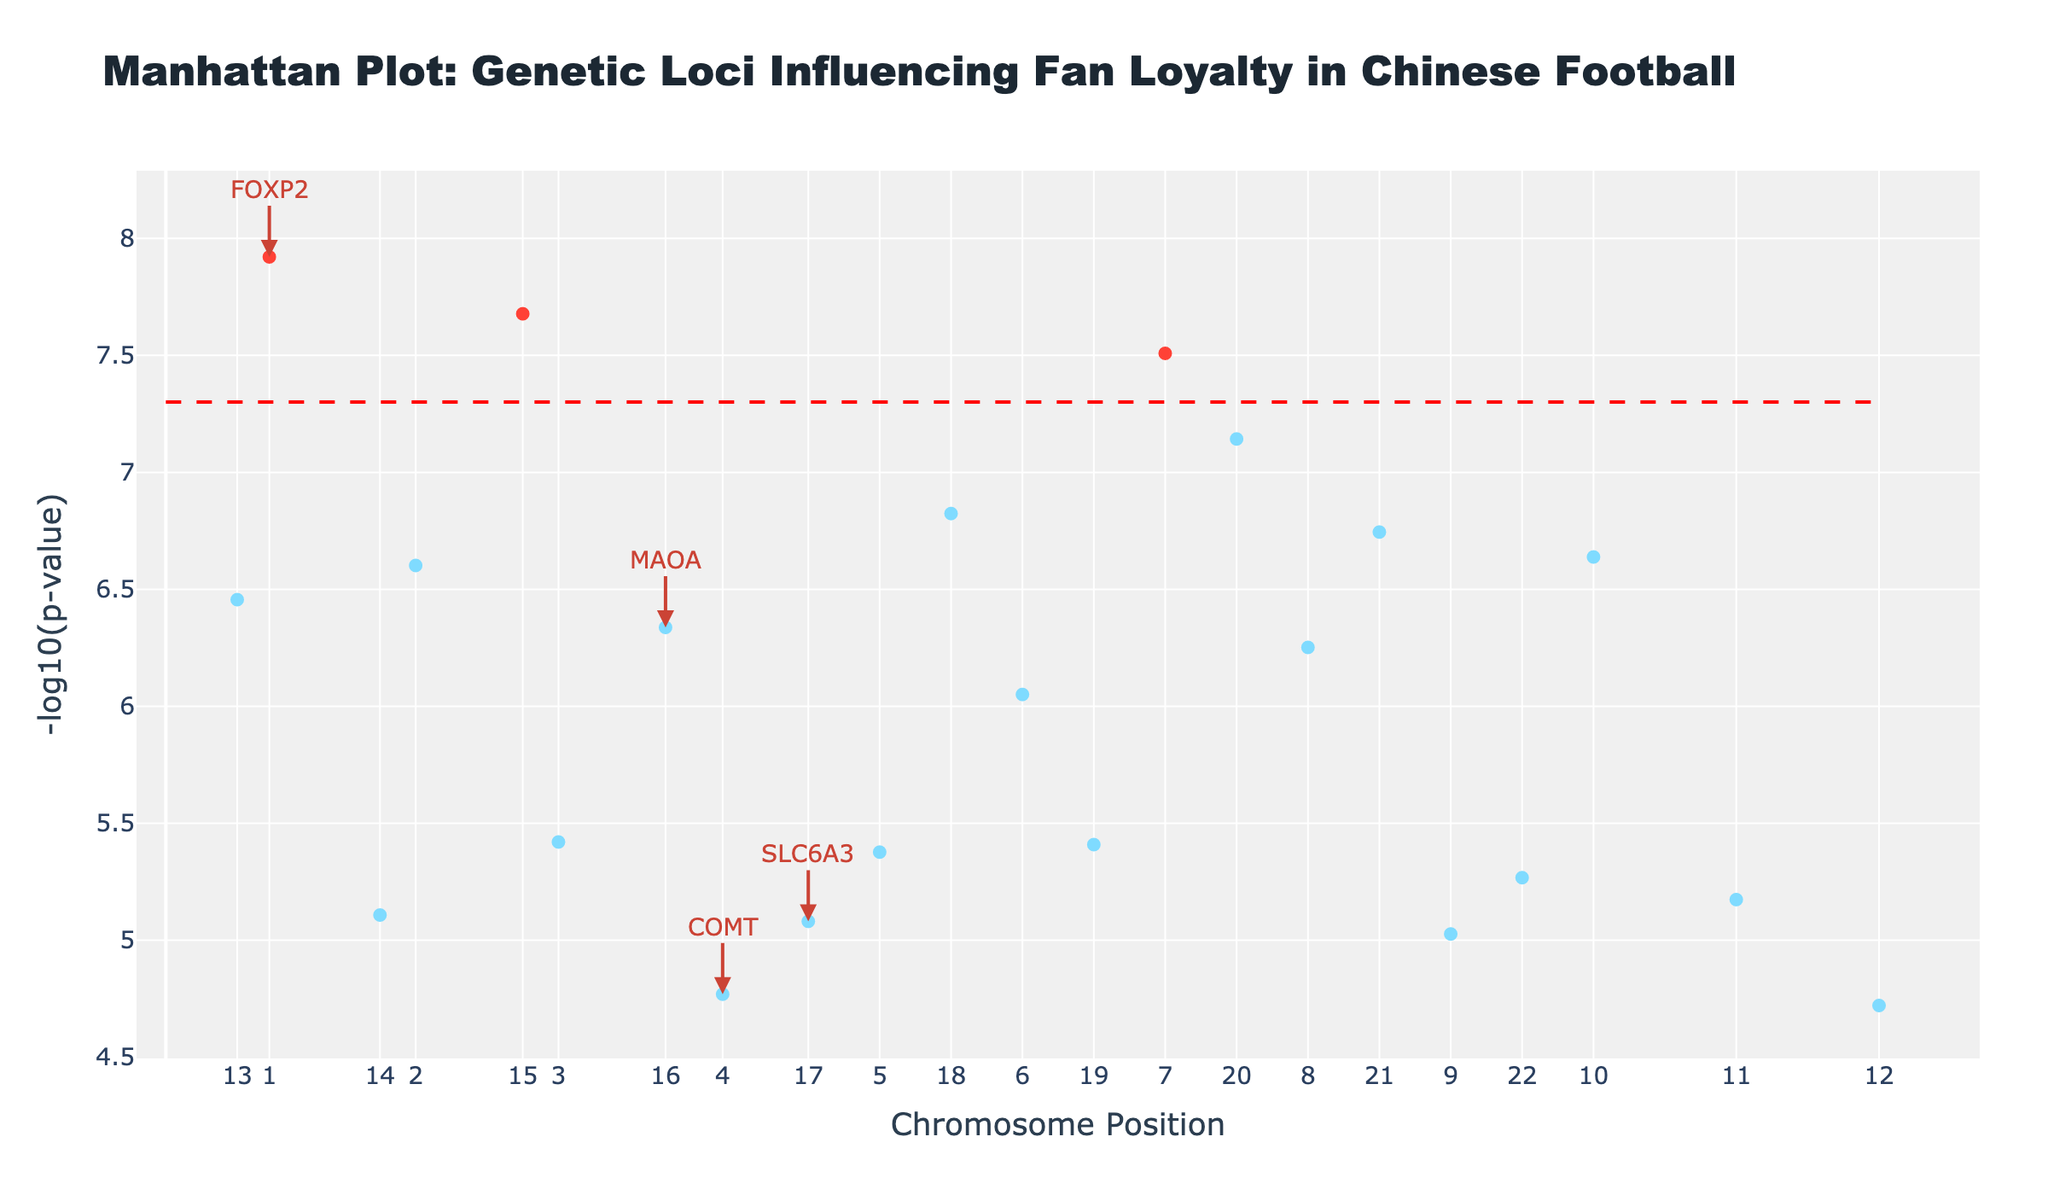what is the title of the plot? By looking at the top of the figure, the title is displayed prominently in larger text. This helps identify the main focus of the plot.
Answer: Manhattan Plot: Genetic Loci Influencing Fan Loyalty in Chinese Football What does the y-axis represent? The y-axis typically shows the significance of each SNP, often represented as the negative logarithm of the p-value (-log10(p-value)). This is found by looking at the y-axis label.
Answer: -log10(p-value) Which SNP has the lowest p-value? By looking for the highest point on the y-axis concerning the -log10(p-value), I can identify the SNP with the lowest p-value. Check the text associated with this highest point to find the SNP name.
Answer: rs2345678 How are significant SNPs visually distinguished? Significant SNPs are usually marked differently, often in a distinct color like red. This can be observed by the presence of differently colored markers in the plot.
Answer: They are in red On which chromosome is the SNP with the association "Euphoria from team victories" located? By identifying the association text "Euphoria from team victories" on the plot, I can then look at the corresponding chromosome number displayed on the x-axis.
Answer: Chromosome 10 How many data points exceed the significance threshold (p=5e-8)? I need to count the number of points that are colored red or that are above the dashed line indicating the significance threshold on the y-axis.
Answer: Four data points Which gene has the highest -log10(p-value) and what is its association? By finding the highest point on the y-axis in the plot, I can check the text annotation to find out the gene name and its association.
Answer: FOXP2, Wuhan Three Towns loyalty Compare the -log10(p-value) for associations "Match attendance frequency" and "Social bonding with fellow fans". Which one is more significant? The -log10(p-value) is higher for more significant associations. By locating both points on the y-axis, I can compare their heights.
Answer: Social bonding with fellow fans What is the chromosome number associated with "Long-term fan commitment"? Find the association "Long-term fan commitment" on the plot, and then identify the corresponding chromosome number on the x-axis.
Answer: Chromosome 9 